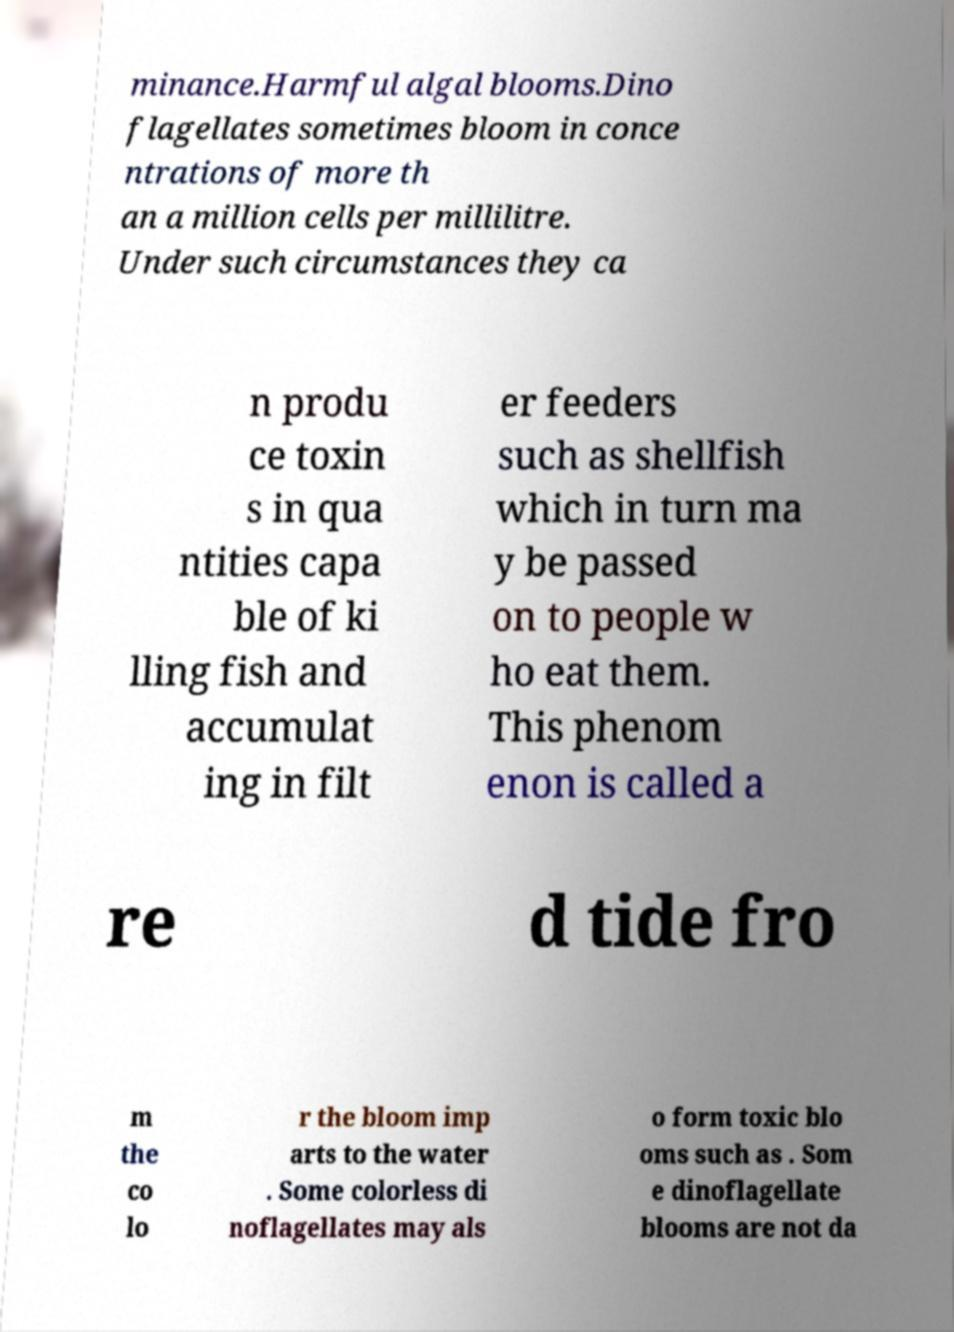Please identify and transcribe the text found in this image. minance.Harmful algal blooms.Dino flagellates sometimes bloom in conce ntrations of more th an a million cells per millilitre. Under such circumstances they ca n produ ce toxin s in qua ntities capa ble of ki lling fish and accumulat ing in filt er feeders such as shellfish which in turn ma y be passed on to people w ho eat them. This phenom enon is called a re d tide fro m the co lo r the bloom imp arts to the water . Some colorless di noflagellates may als o form toxic blo oms such as . Som e dinoflagellate blooms are not da 